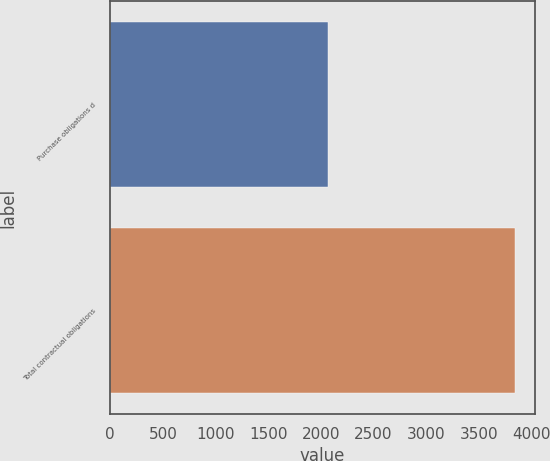<chart> <loc_0><loc_0><loc_500><loc_500><bar_chart><fcel>Purchase obligations d<fcel>Total contractual obligations<nl><fcel>2063<fcel>3839<nl></chart> 